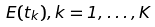<formula> <loc_0><loc_0><loc_500><loc_500>E ( t _ { k } ) , k = 1 , \dots , K</formula> 